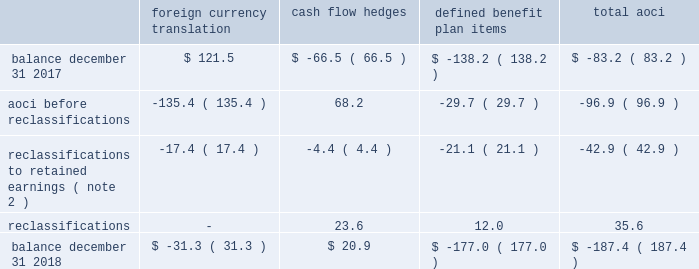Zimmer biomet holdings , inc .
And subsidiaries 2018 form 10-k annual report notes to consolidated financial statements ( continued ) default for unsecured financing arrangements , including , among other things , limitations on consolidations , mergers and sales of assets .
Financial covenants under the 2018 , 2016 and 2014 credit agreements include a consolidated indebtedness to consolidated ebitda ratio of no greater than 5.0 to 1.0 through june 30 , 2017 , and no greater than 4.5 to 1.0 thereafter .
If our credit rating falls below investment grade , additional restrictions would result , including restrictions on investments and payment of dividends .
We were in compliance with all covenants under the 2018 , 2016 and 2014 credit agreements as of december 31 , 2018 .
As of december 31 , 2018 , there were no borrowings outstanding under the multicurrency revolving facility .
We may , at our option , redeem our senior notes , in whole or in part , at any time upon payment of the principal , any applicable make-whole premium , and accrued and unpaid interest to the date of redemption , except that the floating rate notes due 2021 may not be redeemed until on or after march 20 , 2019 and such notes do not have any applicable make-whole premium .
In addition , we may redeem , at our option , the 2.700% ( 2.700 % ) senior notes due 2020 , the 3.375% ( 3.375 % ) senior notes due 2021 , the 3.150% ( 3.150 % ) senior notes due 2022 , the 3.700% ( 3.700 % ) senior notes due 2023 , the 3.550% ( 3.550 % ) senior notes due 2025 , the 4.250% ( 4.250 % ) senior notes due 2035 and the 4.450% ( 4.450 % ) senior notes due 2045 without any make-whole premium at specified dates ranging from one month to six months in advance of the scheduled maturity date .
The estimated fair value of our senior notes as of december 31 , 2018 , based on quoted prices for the specific securities from transactions in over-the-counter markets ( level 2 ) , was $ 7798.9 million .
The estimated fair value of japan term loan a and japan term loan b , in the aggregate , as of december 31 , 2018 , based upon publicly available market yield curves and the terms of the debt ( level 2 ) , was $ 294.7 million .
The carrying values of u.s .
Term loan b and u.s .
Term loan c approximate fair value as they bear interest at short-term variable market rates .
We entered into interest rate swap agreements which we designated as fair value hedges of underlying fixed-rate obligations on our senior notes due 2019 and 2021 .
These fair value hedges were settled in 2016 .
In 2016 , we entered into various variable-to-fixed interest rate swap agreements that were accounted for as cash flow hedges of u.s .
Term loan b .
In 2018 , we entered into cross-currency interest rate swaps that we designated as net investment hedges .
The excluded component of these net investment hedges is recorded in interest expense , net .
See note 13 for additional information regarding our interest rate swap agreements .
We also have available uncommitted credit facilities totaling $ 55.0 million .
At december 31 , 2018 and 2017 , the weighted average interest rate for our borrowings was 3.1 percent and 2.9 percent , respectively .
We paid $ 282.8 million , $ 317.5 million , and $ 363.1 million in interest during 2018 , 2017 , and 2016 , respectively .
12 .
Accumulated other comprehensive ( loss ) income aoci refers to certain gains and losses that under gaap are included in comprehensive income but are excluded from net earnings as these amounts are initially recorded as an adjustment to stockholders 2019 equity .
Amounts in aoci may be reclassified to net earnings upon the occurrence of certain events .
Our aoci is comprised of foreign currency translation adjustments , including unrealized gains and losses on net investment hedges , unrealized gains and losses on cash flow hedges , and amortization of prior service costs and unrecognized gains and losses in actuarial assumptions on our defined benefit plans .
Foreign currency translation adjustments are reclassified to net earnings upon sale or upon a complete or substantially complete liquidation of an investment in a foreign entity .
Unrealized gains and losses on cash flow hedges are reclassified to net earnings when the hedged item affects net earnings .
Amounts related to defined benefit plans that are in aoci are reclassified over the service periods of employees in the plan .
See note 14 for more information on our defined benefit plans .
The table shows the changes in the components of aoci , net of tax ( in millions ) : foreign currency translation hedges defined benefit plan items .

What is the percent change of interest paid between 2016 and 2017? 
Computations: ((317.5 - 363.1) / 363.1)
Answer: -0.12559. 